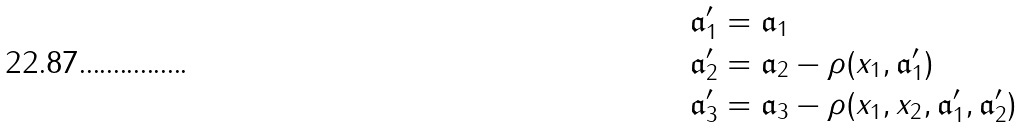Convert formula to latex. <formula><loc_0><loc_0><loc_500><loc_500>\mathfrak { a } _ { 1 } ^ { \prime } & = \mathfrak { a } _ { 1 } \\ \mathfrak { a } _ { 2 } ^ { \prime } & = \mathfrak { a } _ { 2 } - \rho ( x _ { 1 } , \mathfrak { a } _ { 1 } ^ { \prime } ) \\ \mathfrak { a } _ { 3 } ^ { \prime } & = \mathfrak { a } _ { 3 } - \rho ( x _ { 1 } , x _ { 2 } , \mathfrak { a } _ { 1 } ^ { \prime } , \mathfrak { a } _ { 2 } ^ { \prime } )</formula> 